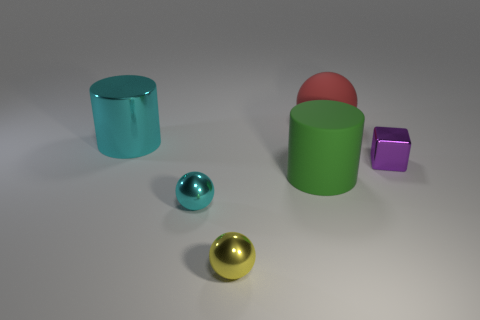Add 2 cyan metal spheres. How many objects exist? 8 Subtract all cylinders. How many objects are left? 4 Add 5 big red things. How many big red things exist? 6 Subtract 0 brown cylinders. How many objects are left? 6 Subtract all small gray objects. Subtract all big objects. How many objects are left? 3 Add 3 large green cylinders. How many large green cylinders are left? 4 